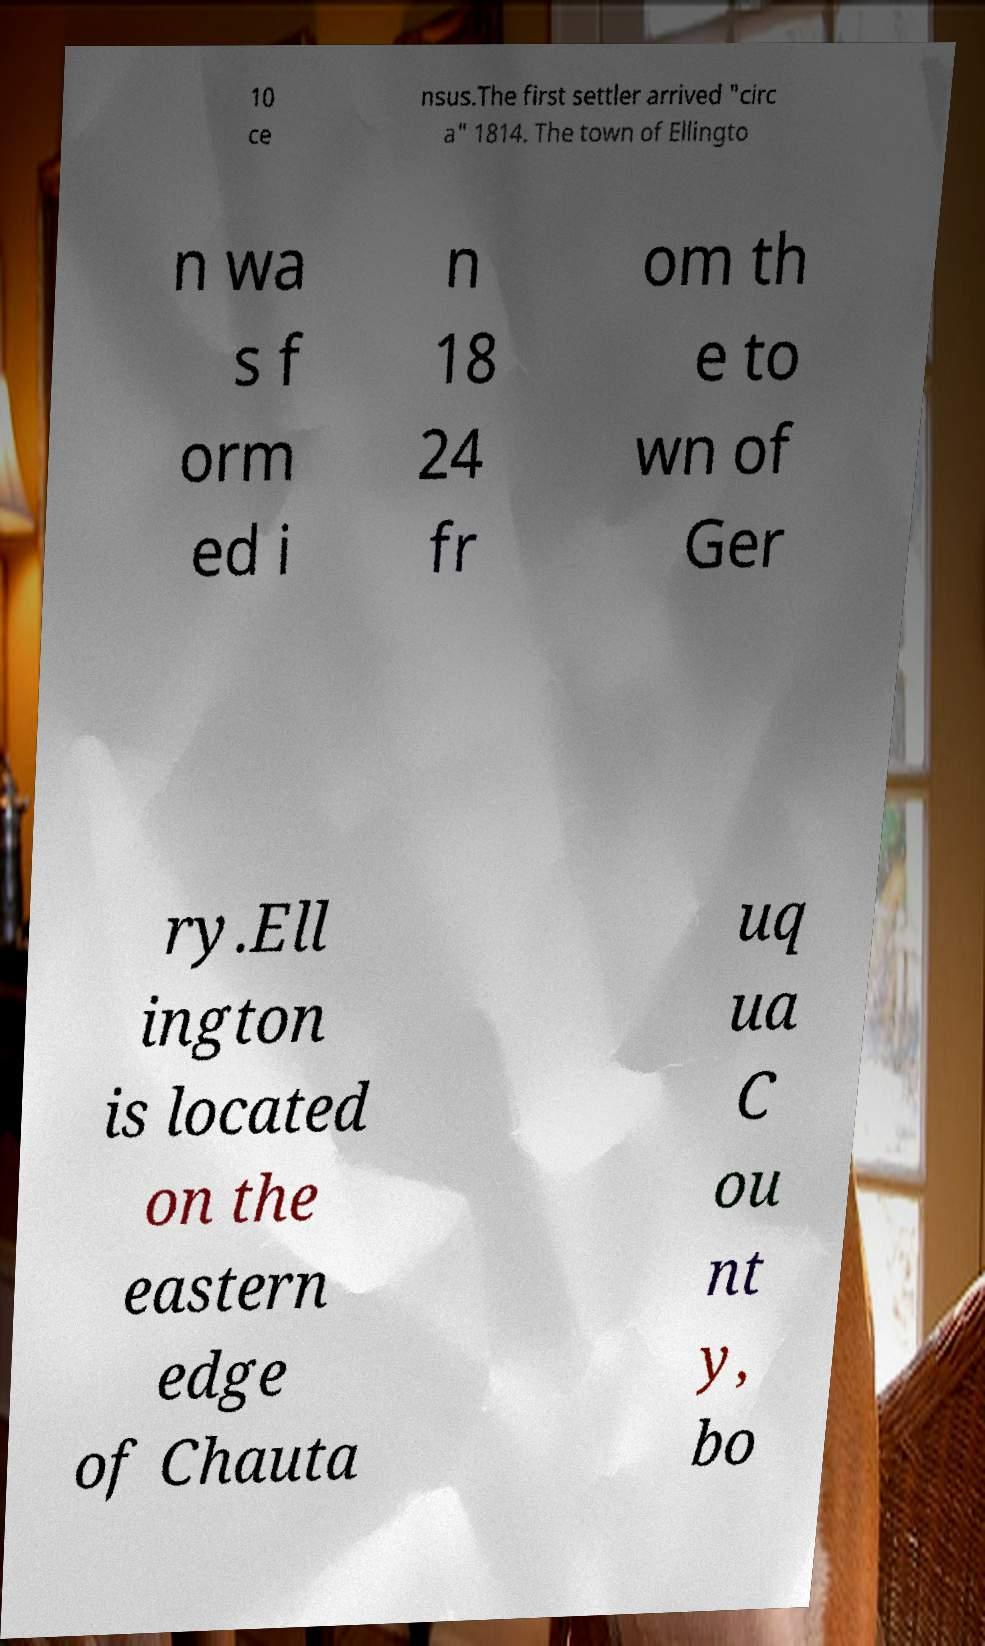For documentation purposes, I need the text within this image transcribed. Could you provide that? 10 ce nsus.The first settler arrived "circ a" 1814. The town of Ellingto n wa s f orm ed i n 18 24 fr om th e to wn of Ger ry.Ell ington is located on the eastern edge of Chauta uq ua C ou nt y, bo 